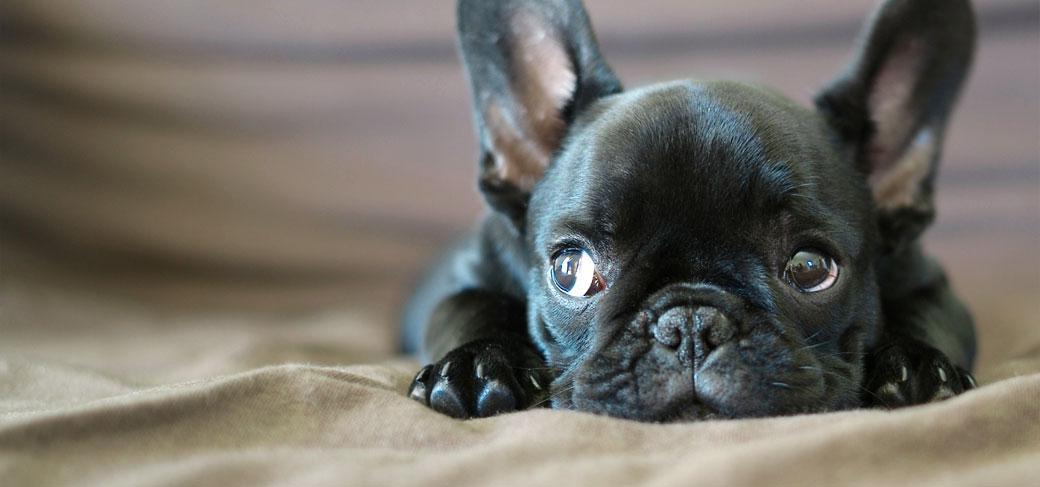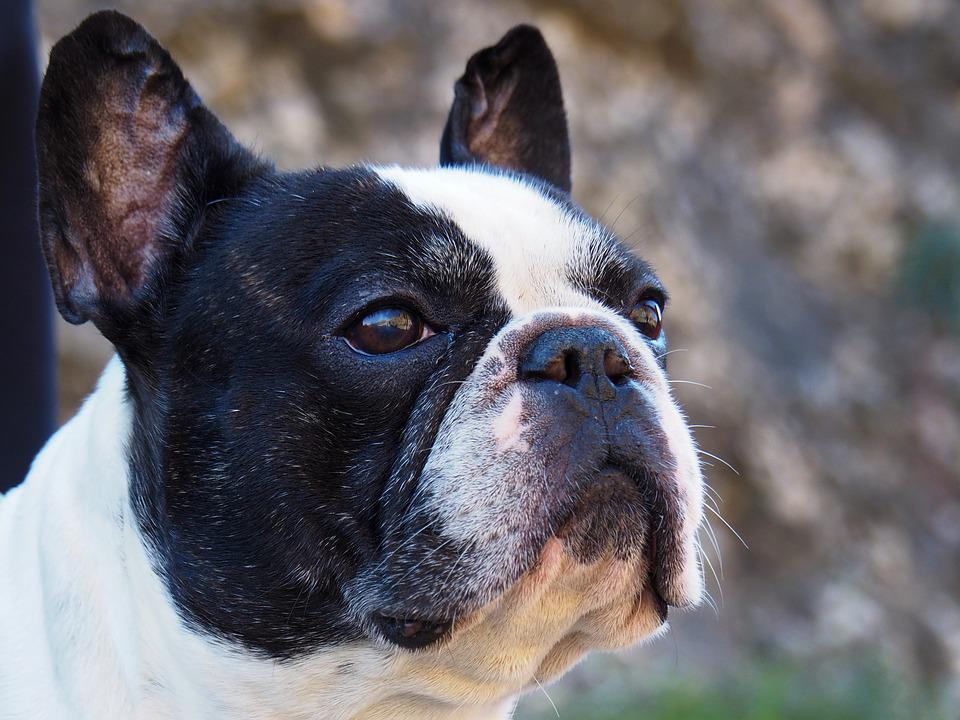The first image is the image on the left, the second image is the image on the right. Assess this claim about the two images: "The dog in the image on the left is lying down.". Correct or not? Answer yes or no. Yes. The first image is the image on the left, the second image is the image on the right. For the images shown, is this caption "The left image features a dark big-eared puppy reclining on its belly with both paws forward and visible, with its body turned forward and its eyes glancing sideways." true? Answer yes or no. Yes. 